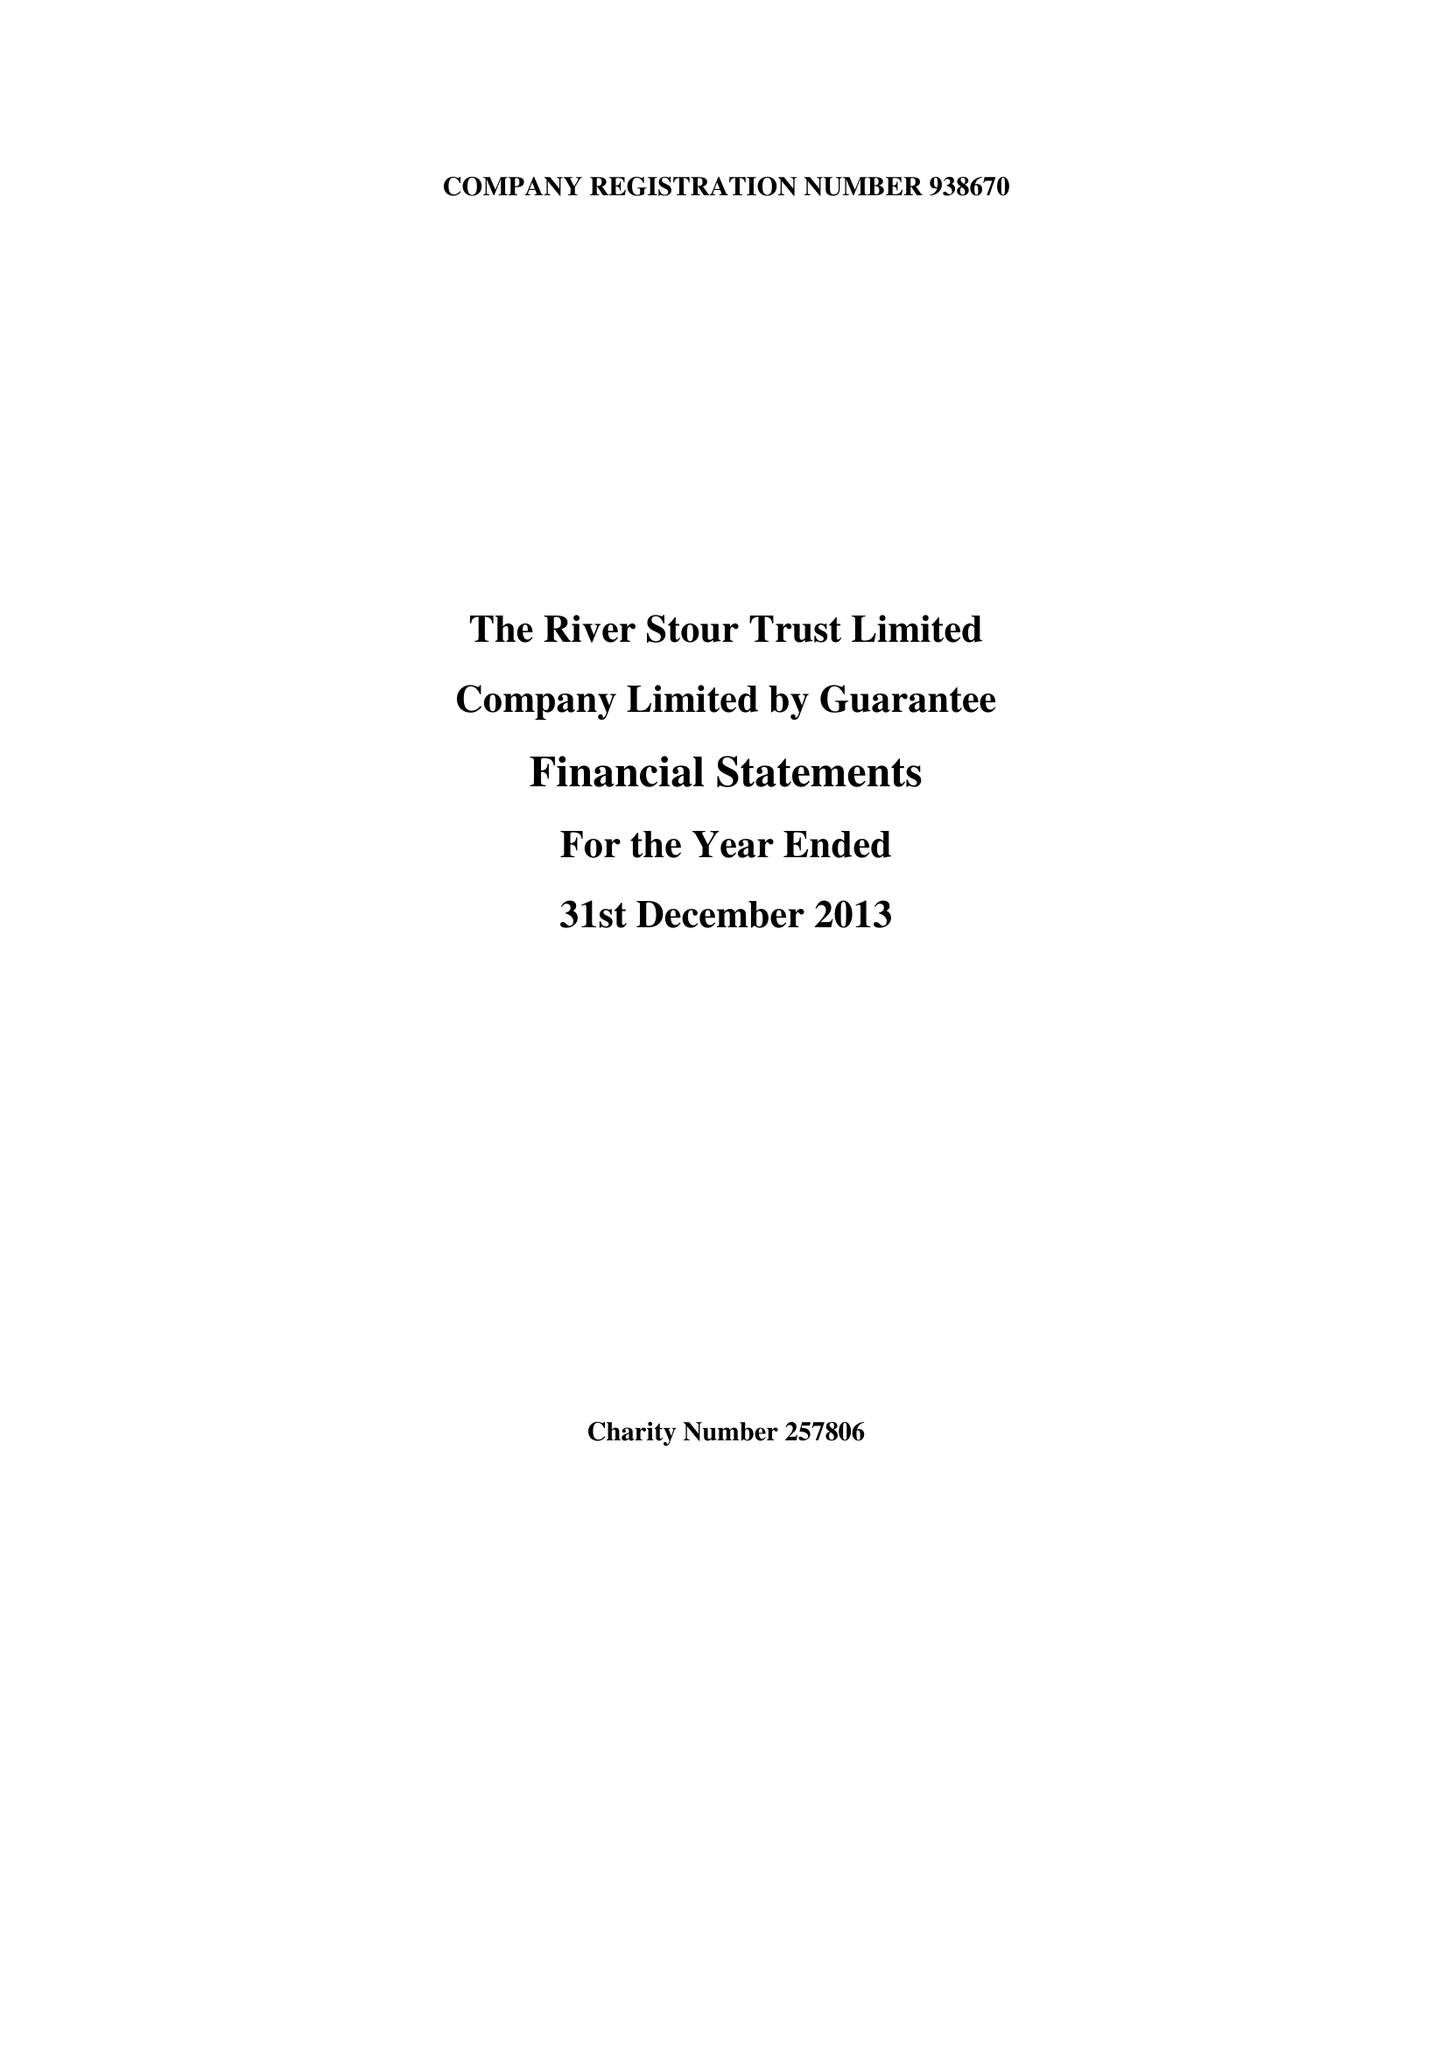What is the value for the spending_annually_in_british_pounds?
Answer the question using a single word or phrase. 81147.00 